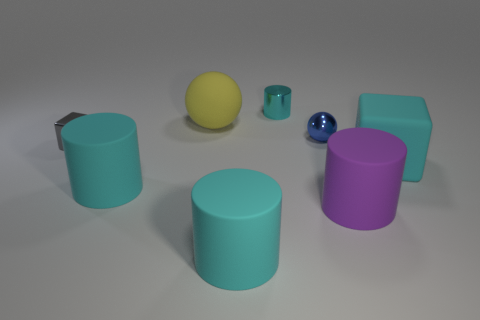What number of matte objects are large cylinders or cubes?
Your response must be concise. 4. What size is the blue metal sphere?
Your answer should be compact. Small. How many objects are small metal things or large cyan matte objects that are left of the large cyan block?
Make the answer very short. 5. What number of other things are the same color as the small metal sphere?
Your answer should be compact. 0. Do the blue object and the cyan object right of the shiny cylinder have the same size?
Your response must be concise. No. Does the cyan cylinder that is behind the matte ball have the same size as the blue thing?
Your answer should be very brief. Yes. How many other things are the same material as the blue thing?
Ensure brevity in your answer.  2. Are there the same number of purple matte objects in front of the purple cylinder and spheres that are to the right of the tiny cyan metallic object?
Keep it short and to the point. No. What is the color of the matte thing that is right of the large purple thing that is right of the cyan cylinder behind the large cyan rubber block?
Your response must be concise. Cyan. There is a matte object behind the cyan block; what shape is it?
Provide a succinct answer. Sphere. 